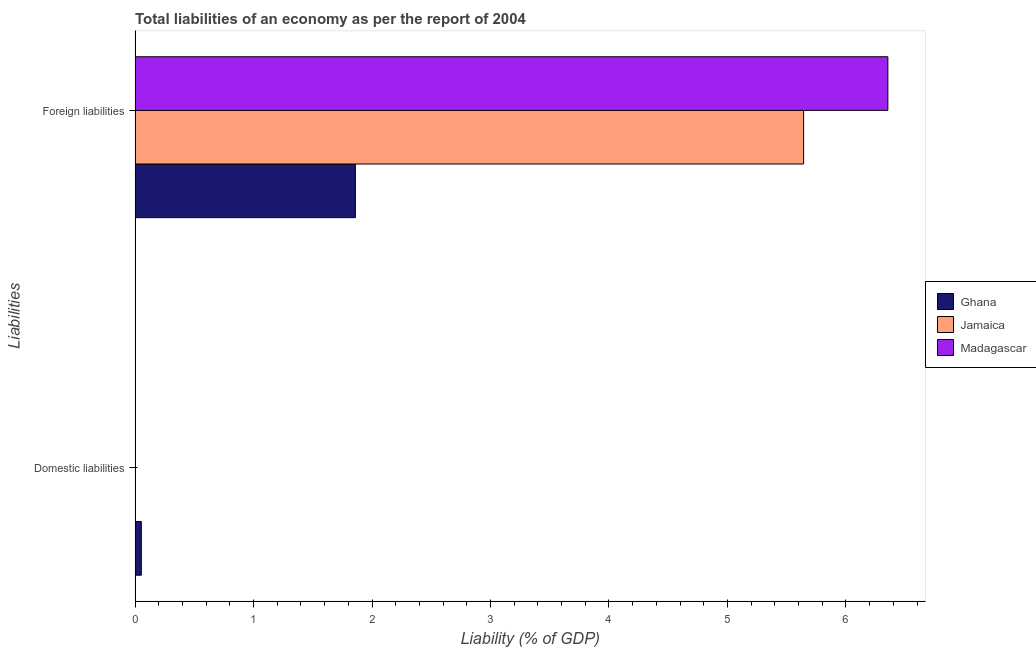How many different coloured bars are there?
Make the answer very short. 3. Are the number of bars per tick equal to the number of legend labels?
Your answer should be compact. No. Are the number of bars on each tick of the Y-axis equal?
Your answer should be compact. No. How many bars are there on the 2nd tick from the top?
Offer a very short reply. 1. What is the label of the 2nd group of bars from the top?
Your answer should be compact. Domestic liabilities. What is the incurrence of foreign liabilities in Jamaica?
Provide a succinct answer. 5.64. Across all countries, what is the maximum incurrence of domestic liabilities?
Offer a terse response. 0.05. What is the total incurrence of domestic liabilities in the graph?
Your answer should be very brief. 0.05. What is the difference between the incurrence of foreign liabilities in Ghana and that in Madagascar?
Offer a terse response. -4.49. What is the difference between the incurrence of domestic liabilities in Madagascar and the incurrence of foreign liabilities in Ghana?
Offer a terse response. -1.86. What is the average incurrence of domestic liabilities per country?
Make the answer very short. 0.02. What is the difference between the incurrence of foreign liabilities and incurrence of domestic liabilities in Ghana?
Give a very brief answer. 1.81. What is the ratio of the incurrence of foreign liabilities in Jamaica to that in Madagascar?
Provide a short and direct response. 0.89. Is the incurrence of foreign liabilities in Madagascar less than that in Ghana?
Your response must be concise. No. In how many countries, is the incurrence of domestic liabilities greater than the average incurrence of domestic liabilities taken over all countries?
Make the answer very short. 1. How many bars are there?
Provide a short and direct response. 4. What is the difference between two consecutive major ticks on the X-axis?
Offer a very short reply. 1. Are the values on the major ticks of X-axis written in scientific E-notation?
Your answer should be compact. No. Does the graph contain any zero values?
Your answer should be compact. Yes. How many legend labels are there?
Your response must be concise. 3. What is the title of the graph?
Keep it short and to the point. Total liabilities of an economy as per the report of 2004. What is the label or title of the X-axis?
Give a very brief answer. Liability (% of GDP). What is the label or title of the Y-axis?
Your answer should be compact. Liabilities. What is the Liability (% of GDP) of Ghana in Domestic liabilities?
Keep it short and to the point. 0.05. What is the Liability (% of GDP) of Jamaica in Domestic liabilities?
Provide a succinct answer. 0. What is the Liability (% of GDP) of Madagascar in Domestic liabilities?
Your answer should be very brief. 0. What is the Liability (% of GDP) in Ghana in Foreign liabilities?
Give a very brief answer. 1.86. What is the Liability (% of GDP) in Jamaica in Foreign liabilities?
Offer a terse response. 5.64. What is the Liability (% of GDP) in Madagascar in Foreign liabilities?
Give a very brief answer. 6.35. Across all Liabilities, what is the maximum Liability (% of GDP) of Ghana?
Make the answer very short. 1.86. Across all Liabilities, what is the maximum Liability (% of GDP) in Jamaica?
Provide a succinct answer. 5.64. Across all Liabilities, what is the maximum Liability (% of GDP) in Madagascar?
Keep it short and to the point. 6.35. Across all Liabilities, what is the minimum Liability (% of GDP) of Ghana?
Give a very brief answer. 0.05. Across all Liabilities, what is the minimum Liability (% of GDP) of Jamaica?
Make the answer very short. 0. Across all Liabilities, what is the minimum Liability (% of GDP) of Madagascar?
Your answer should be very brief. 0. What is the total Liability (% of GDP) in Ghana in the graph?
Your answer should be very brief. 1.91. What is the total Liability (% of GDP) in Jamaica in the graph?
Keep it short and to the point. 5.64. What is the total Liability (% of GDP) of Madagascar in the graph?
Your response must be concise. 6.35. What is the difference between the Liability (% of GDP) of Ghana in Domestic liabilities and that in Foreign liabilities?
Make the answer very short. -1.81. What is the difference between the Liability (% of GDP) in Ghana in Domestic liabilities and the Liability (% of GDP) in Jamaica in Foreign liabilities?
Ensure brevity in your answer.  -5.59. What is the difference between the Liability (% of GDP) of Ghana in Domestic liabilities and the Liability (% of GDP) of Madagascar in Foreign liabilities?
Keep it short and to the point. -6.3. What is the average Liability (% of GDP) of Ghana per Liabilities?
Your response must be concise. 0.96. What is the average Liability (% of GDP) of Jamaica per Liabilities?
Your response must be concise. 2.82. What is the average Liability (% of GDP) of Madagascar per Liabilities?
Offer a very short reply. 3.18. What is the difference between the Liability (% of GDP) of Ghana and Liability (% of GDP) of Jamaica in Foreign liabilities?
Your answer should be compact. -3.78. What is the difference between the Liability (% of GDP) of Ghana and Liability (% of GDP) of Madagascar in Foreign liabilities?
Ensure brevity in your answer.  -4.49. What is the difference between the Liability (% of GDP) in Jamaica and Liability (% of GDP) in Madagascar in Foreign liabilities?
Give a very brief answer. -0.71. What is the ratio of the Liability (% of GDP) of Ghana in Domestic liabilities to that in Foreign liabilities?
Provide a short and direct response. 0.03. What is the difference between the highest and the second highest Liability (% of GDP) of Ghana?
Your response must be concise. 1.81. What is the difference between the highest and the lowest Liability (% of GDP) in Ghana?
Make the answer very short. 1.81. What is the difference between the highest and the lowest Liability (% of GDP) in Jamaica?
Your answer should be very brief. 5.64. What is the difference between the highest and the lowest Liability (% of GDP) of Madagascar?
Your response must be concise. 6.35. 